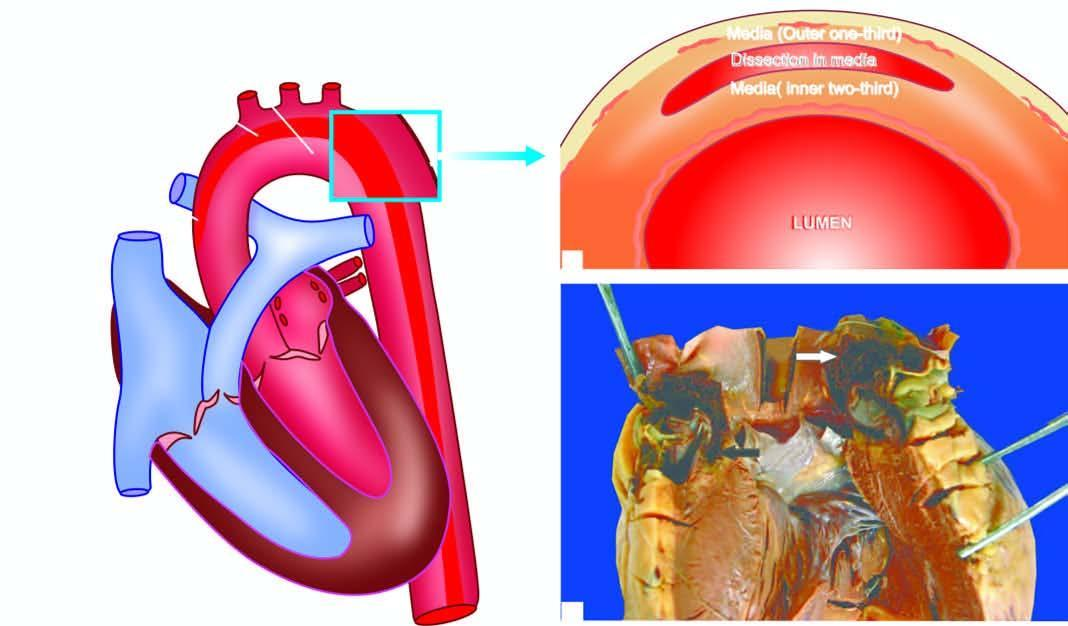s the corresponding area seen in the arch?
Answer the question using a single word or phrase. No 